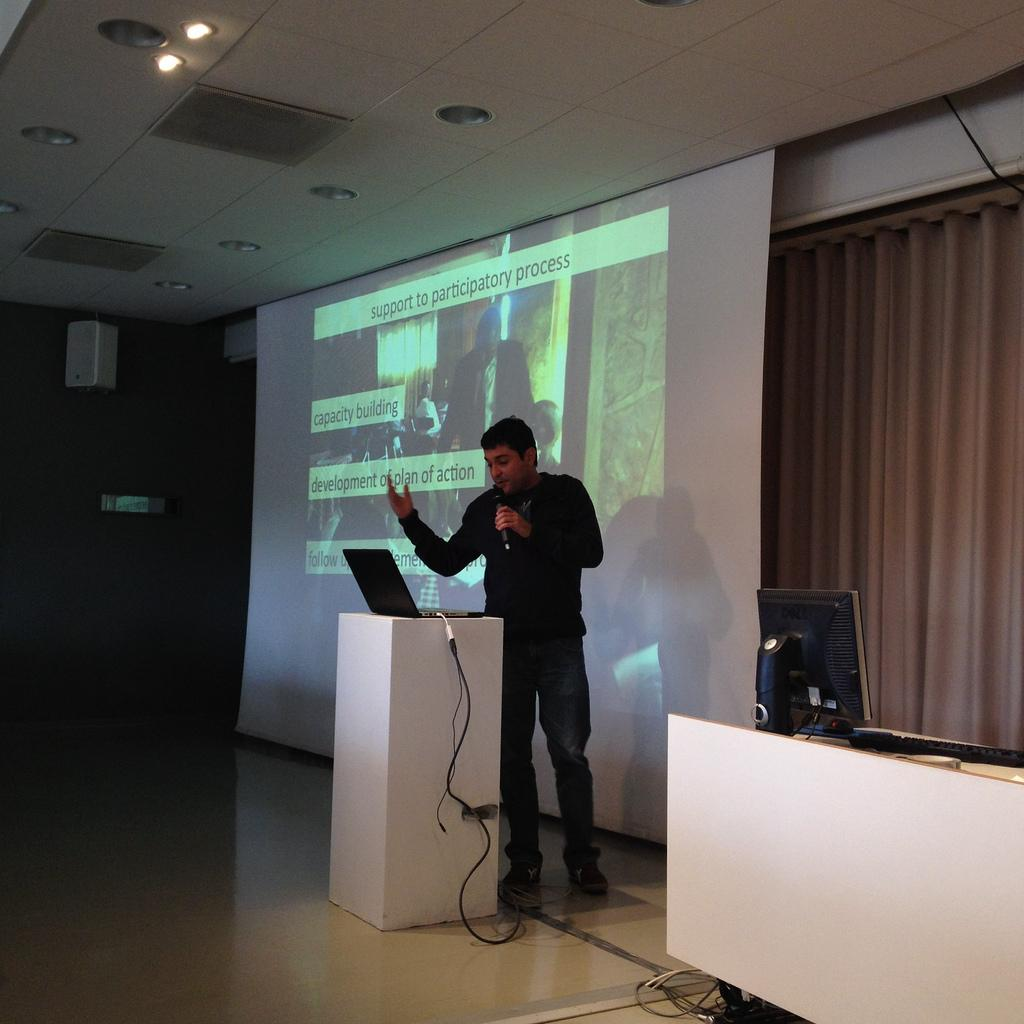Provide a one-sentence caption for the provided image. The screen has a slide that is titled, "support to participatory process.". 